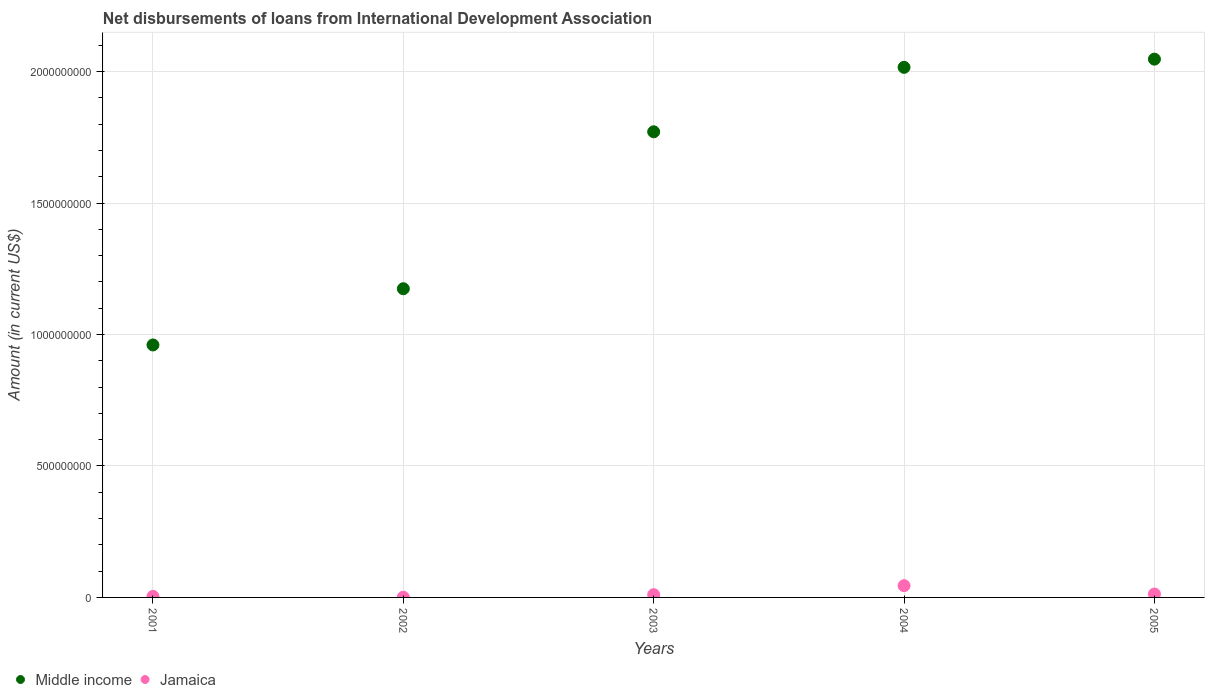How many different coloured dotlines are there?
Make the answer very short. 2. Is the number of dotlines equal to the number of legend labels?
Your answer should be compact. Yes. What is the amount of loans disbursed in Middle income in 2003?
Ensure brevity in your answer.  1.77e+09. Across all years, what is the maximum amount of loans disbursed in Jamaica?
Provide a short and direct response. 4.47e+07. Across all years, what is the minimum amount of loans disbursed in Jamaica?
Your answer should be very brief. 8.36e+05. In which year was the amount of loans disbursed in Jamaica minimum?
Make the answer very short. 2002. What is the total amount of loans disbursed in Middle income in the graph?
Ensure brevity in your answer.  7.97e+09. What is the difference between the amount of loans disbursed in Middle income in 2001 and that in 2002?
Offer a very short reply. -2.14e+08. What is the difference between the amount of loans disbursed in Jamaica in 2002 and the amount of loans disbursed in Middle income in 2003?
Your response must be concise. -1.77e+09. What is the average amount of loans disbursed in Jamaica per year?
Provide a short and direct response. 1.46e+07. In the year 2001, what is the difference between the amount of loans disbursed in Middle income and amount of loans disbursed in Jamaica?
Your answer should be very brief. 9.56e+08. What is the ratio of the amount of loans disbursed in Middle income in 2003 to that in 2005?
Give a very brief answer. 0.87. What is the difference between the highest and the second highest amount of loans disbursed in Jamaica?
Your answer should be compact. 3.18e+07. What is the difference between the highest and the lowest amount of loans disbursed in Middle income?
Provide a succinct answer. 1.09e+09. In how many years, is the amount of loans disbursed in Middle income greater than the average amount of loans disbursed in Middle income taken over all years?
Keep it short and to the point. 3. Is the amount of loans disbursed in Middle income strictly greater than the amount of loans disbursed in Jamaica over the years?
Ensure brevity in your answer.  Yes. Is the amount of loans disbursed in Middle income strictly less than the amount of loans disbursed in Jamaica over the years?
Your response must be concise. No. How many years are there in the graph?
Ensure brevity in your answer.  5. Does the graph contain any zero values?
Your response must be concise. No. Does the graph contain grids?
Provide a succinct answer. Yes. Where does the legend appear in the graph?
Give a very brief answer. Bottom left. How many legend labels are there?
Your response must be concise. 2. What is the title of the graph?
Ensure brevity in your answer.  Net disbursements of loans from International Development Association. What is the label or title of the X-axis?
Provide a short and direct response. Years. What is the Amount (in current US$) in Middle income in 2001?
Your answer should be very brief. 9.60e+08. What is the Amount (in current US$) of Jamaica in 2001?
Offer a very short reply. 3.93e+06. What is the Amount (in current US$) in Middle income in 2002?
Your answer should be very brief. 1.17e+09. What is the Amount (in current US$) in Jamaica in 2002?
Ensure brevity in your answer.  8.36e+05. What is the Amount (in current US$) in Middle income in 2003?
Offer a very short reply. 1.77e+09. What is the Amount (in current US$) of Jamaica in 2003?
Your answer should be very brief. 1.05e+07. What is the Amount (in current US$) of Middle income in 2004?
Provide a succinct answer. 2.02e+09. What is the Amount (in current US$) in Jamaica in 2004?
Make the answer very short. 4.47e+07. What is the Amount (in current US$) of Middle income in 2005?
Ensure brevity in your answer.  2.05e+09. What is the Amount (in current US$) of Jamaica in 2005?
Keep it short and to the point. 1.29e+07. Across all years, what is the maximum Amount (in current US$) of Middle income?
Provide a short and direct response. 2.05e+09. Across all years, what is the maximum Amount (in current US$) in Jamaica?
Offer a terse response. 4.47e+07. Across all years, what is the minimum Amount (in current US$) in Middle income?
Your answer should be compact. 9.60e+08. Across all years, what is the minimum Amount (in current US$) in Jamaica?
Your answer should be compact. 8.36e+05. What is the total Amount (in current US$) of Middle income in the graph?
Offer a very short reply. 7.97e+09. What is the total Amount (in current US$) in Jamaica in the graph?
Your response must be concise. 7.29e+07. What is the difference between the Amount (in current US$) in Middle income in 2001 and that in 2002?
Give a very brief answer. -2.14e+08. What is the difference between the Amount (in current US$) of Jamaica in 2001 and that in 2002?
Provide a succinct answer. 3.10e+06. What is the difference between the Amount (in current US$) in Middle income in 2001 and that in 2003?
Give a very brief answer. -8.11e+08. What is the difference between the Amount (in current US$) in Jamaica in 2001 and that in 2003?
Give a very brief answer. -6.56e+06. What is the difference between the Amount (in current US$) of Middle income in 2001 and that in 2004?
Offer a very short reply. -1.06e+09. What is the difference between the Amount (in current US$) of Jamaica in 2001 and that in 2004?
Make the answer very short. -4.08e+07. What is the difference between the Amount (in current US$) of Middle income in 2001 and that in 2005?
Keep it short and to the point. -1.09e+09. What is the difference between the Amount (in current US$) of Jamaica in 2001 and that in 2005?
Your response must be concise. -8.95e+06. What is the difference between the Amount (in current US$) of Middle income in 2002 and that in 2003?
Keep it short and to the point. -5.97e+08. What is the difference between the Amount (in current US$) of Jamaica in 2002 and that in 2003?
Offer a very short reply. -9.65e+06. What is the difference between the Amount (in current US$) of Middle income in 2002 and that in 2004?
Your response must be concise. -8.42e+08. What is the difference between the Amount (in current US$) of Jamaica in 2002 and that in 2004?
Your response must be concise. -4.39e+07. What is the difference between the Amount (in current US$) of Middle income in 2002 and that in 2005?
Offer a terse response. -8.73e+08. What is the difference between the Amount (in current US$) of Jamaica in 2002 and that in 2005?
Provide a short and direct response. -1.20e+07. What is the difference between the Amount (in current US$) in Middle income in 2003 and that in 2004?
Give a very brief answer. -2.45e+08. What is the difference between the Amount (in current US$) of Jamaica in 2003 and that in 2004?
Provide a short and direct response. -3.42e+07. What is the difference between the Amount (in current US$) in Middle income in 2003 and that in 2005?
Provide a succinct answer. -2.76e+08. What is the difference between the Amount (in current US$) of Jamaica in 2003 and that in 2005?
Give a very brief answer. -2.40e+06. What is the difference between the Amount (in current US$) of Middle income in 2004 and that in 2005?
Your answer should be compact. -3.11e+07. What is the difference between the Amount (in current US$) in Jamaica in 2004 and that in 2005?
Give a very brief answer. 3.18e+07. What is the difference between the Amount (in current US$) in Middle income in 2001 and the Amount (in current US$) in Jamaica in 2002?
Your response must be concise. 9.59e+08. What is the difference between the Amount (in current US$) in Middle income in 2001 and the Amount (in current US$) in Jamaica in 2003?
Your answer should be compact. 9.50e+08. What is the difference between the Amount (in current US$) in Middle income in 2001 and the Amount (in current US$) in Jamaica in 2004?
Ensure brevity in your answer.  9.16e+08. What is the difference between the Amount (in current US$) of Middle income in 2001 and the Amount (in current US$) of Jamaica in 2005?
Ensure brevity in your answer.  9.47e+08. What is the difference between the Amount (in current US$) of Middle income in 2002 and the Amount (in current US$) of Jamaica in 2003?
Give a very brief answer. 1.16e+09. What is the difference between the Amount (in current US$) in Middle income in 2002 and the Amount (in current US$) in Jamaica in 2004?
Your response must be concise. 1.13e+09. What is the difference between the Amount (in current US$) in Middle income in 2002 and the Amount (in current US$) in Jamaica in 2005?
Ensure brevity in your answer.  1.16e+09. What is the difference between the Amount (in current US$) of Middle income in 2003 and the Amount (in current US$) of Jamaica in 2004?
Your answer should be compact. 1.73e+09. What is the difference between the Amount (in current US$) of Middle income in 2003 and the Amount (in current US$) of Jamaica in 2005?
Offer a very short reply. 1.76e+09. What is the difference between the Amount (in current US$) of Middle income in 2004 and the Amount (in current US$) of Jamaica in 2005?
Your answer should be compact. 2.00e+09. What is the average Amount (in current US$) in Middle income per year?
Make the answer very short. 1.59e+09. What is the average Amount (in current US$) of Jamaica per year?
Provide a succinct answer. 1.46e+07. In the year 2001, what is the difference between the Amount (in current US$) in Middle income and Amount (in current US$) in Jamaica?
Make the answer very short. 9.56e+08. In the year 2002, what is the difference between the Amount (in current US$) of Middle income and Amount (in current US$) of Jamaica?
Ensure brevity in your answer.  1.17e+09. In the year 2003, what is the difference between the Amount (in current US$) in Middle income and Amount (in current US$) in Jamaica?
Offer a terse response. 1.76e+09. In the year 2004, what is the difference between the Amount (in current US$) in Middle income and Amount (in current US$) in Jamaica?
Offer a terse response. 1.97e+09. In the year 2005, what is the difference between the Amount (in current US$) of Middle income and Amount (in current US$) of Jamaica?
Your answer should be compact. 2.03e+09. What is the ratio of the Amount (in current US$) in Middle income in 2001 to that in 2002?
Your answer should be very brief. 0.82. What is the ratio of the Amount (in current US$) in Jamaica in 2001 to that in 2002?
Your response must be concise. 4.71. What is the ratio of the Amount (in current US$) in Middle income in 2001 to that in 2003?
Your answer should be compact. 0.54. What is the ratio of the Amount (in current US$) in Jamaica in 2001 to that in 2003?
Ensure brevity in your answer.  0.38. What is the ratio of the Amount (in current US$) in Middle income in 2001 to that in 2004?
Your answer should be very brief. 0.48. What is the ratio of the Amount (in current US$) in Jamaica in 2001 to that in 2004?
Provide a short and direct response. 0.09. What is the ratio of the Amount (in current US$) in Middle income in 2001 to that in 2005?
Keep it short and to the point. 0.47. What is the ratio of the Amount (in current US$) in Jamaica in 2001 to that in 2005?
Offer a terse response. 0.31. What is the ratio of the Amount (in current US$) of Middle income in 2002 to that in 2003?
Keep it short and to the point. 0.66. What is the ratio of the Amount (in current US$) of Jamaica in 2002 to that in 2003?
Your response must be concise. 0.08. What is the ratio of the Amount (in current US$) in Middle income in 2002 to that in 2004?
Ensure brevity in your answer.  0.58. What is the ratio of the Amount (in current US$) in Jamaica in 2002 to that in 2004?
Your response must be concise. 0.02. What is the ratio of the Amount (in current US$) of Middle income in 2002 to that in 2005?
Your answer should be very brief. 0.57. What is the ratio of the Amount (in current US$) in Jamaica in 2002 to that in 2005?
Offer a terse response. 0.06. What is the ratio of the Amount (in current US$) of Middle income in 2003 to that in 2004?
Your answer should be compact. 0.88. What is the ratio of the Amount (in current US$) in Jamaica in 2003 to that in 2004?
Make the answer very short. 0.23. What is the ratio of the Amount (in current US$) in Middle income in 2003 to that in 2005?
Your answer should be compact. 0.86. What is the ratio of the Amount (in current US$) in Jamaica in 2003 to that in 2005?
Your answer should be compact. 0.81. What is the ratio of the Amount (in current US$) of Middle income in 2004 to that in 2005?
Keep it short and to the point. 0.98. What is the ratio of the Amount (in current US$) in Jamaica in 2004 to that in 2005?
Provide a short and direct response. 3.47. What is the difference between the highest and the second highest Amount (in current US$) in Middle income?
Offer a terse response. 3.11e+07. What is the difference between the highest and the second highest Amount (in current US$) of Jamaica?
Provide a short and direct response. 3.18e+07. What is the difference between the highest and the lowest Amount (in current US$) of Middle income?
Offer a very short reply. 1.09e+09. What is the difference between the highest and the lowest Amount (in current US$) in Jamaica?
Offer a terse response. 4.39e+07. 